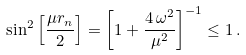Convert formula to latex. <formula><loc_0><loc_0><loc_500><loc_500>\sin ^ { 2 } \left [ \frac { \mu r _ { n } } { 2 } \right ] = \left [ 1 + \frac { 4 \, \omega ^ { 2 } } { \mu ^ { 2 } } \right ] ^ { - 1 } \leq 1 \, .</formula> 